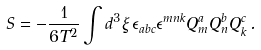<formula> <loc_0><loc_0><loc_500><loc_500>S = - { \frac { 1 } { 6 T ^ { 2 } } } \int d ^ { 3 } \xi \, \epsilon _ { a b c } \epsilon ^ { m n k } Q _ { m } ^ { a } Q _ { n } ^ { b } Q _ { k } ^ { c } \, .</formula> 